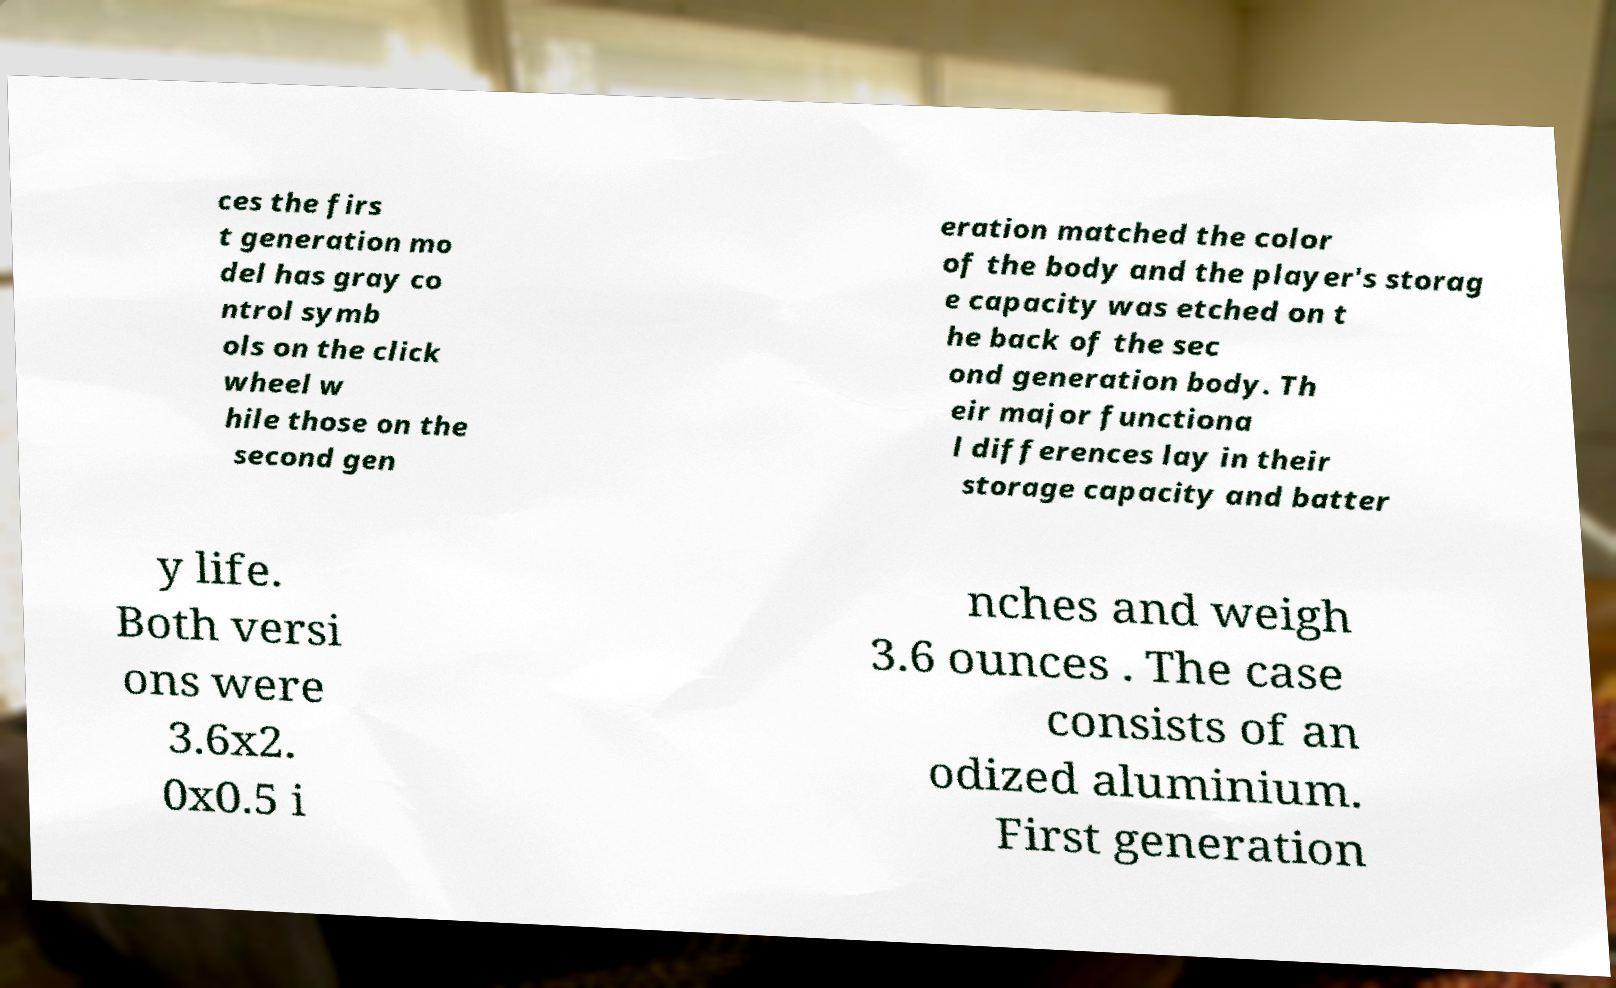What messages or text are displayed in this image? I need them in a readable, typed format. ces the firs t generation mo del has gray co ntrol symb ols on the click wheel w hile those on the second gen eration matched the color of the body and the player's storag e capacity was etched on t he back of the sec ond generation body. Th eir major functiona l differences lay in their storage capacity and batter y life. Both versi ons were 3.6x2. 0x0.5 i nches and weigh 3.6 ounces . The case consists of an odized aluminium. First generation 